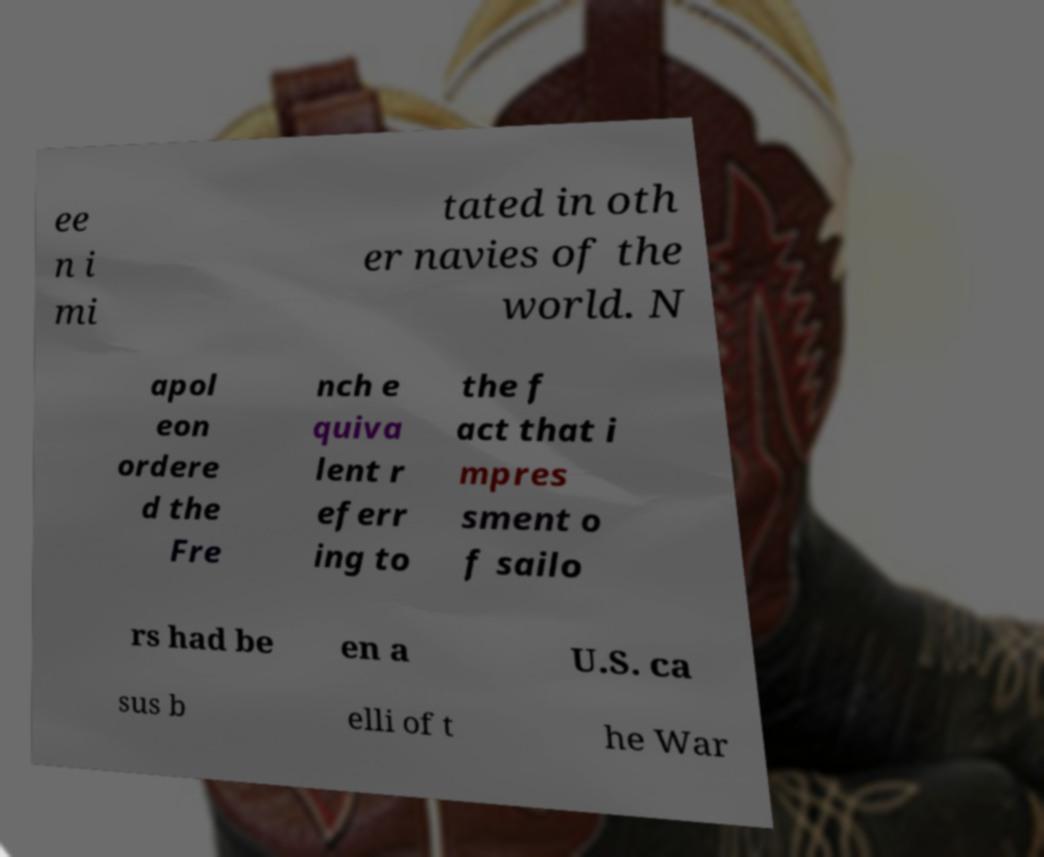For documentation purposes, I need the text within this image transcribed. Could you provide that? ee n i mi tated in oth er navies of the world. N apol eon ordere d the Fre nch e quiva lent r eferr ing to the f act that i mpres sment o f sailo rs had be en a U.S. ca sus b elli of t he War 